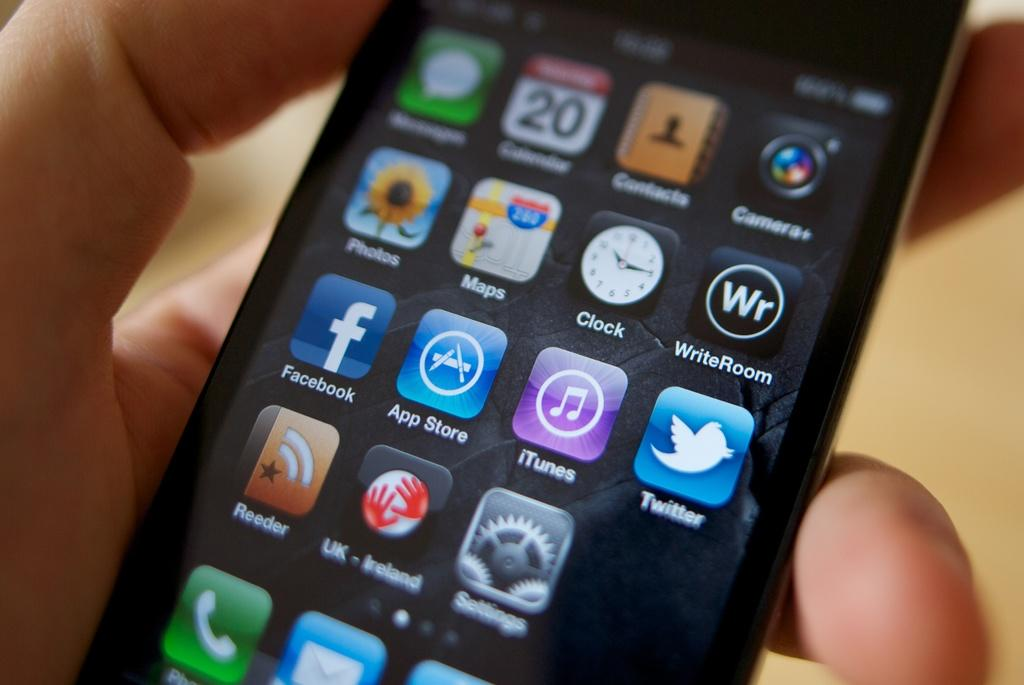<image>
Create a compact narrative representing the image presented. A screen of an iPhone showing various apps including Facebook, the app store and Twitter. 